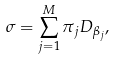Convert formula to latex. <formula><loc_0><loc_0><loc_500><loc_500>\sigma = \sum _ { j = 1 } ^ { M } \pi _ { j } D _ { \beta _ { j } } ,</formula> 